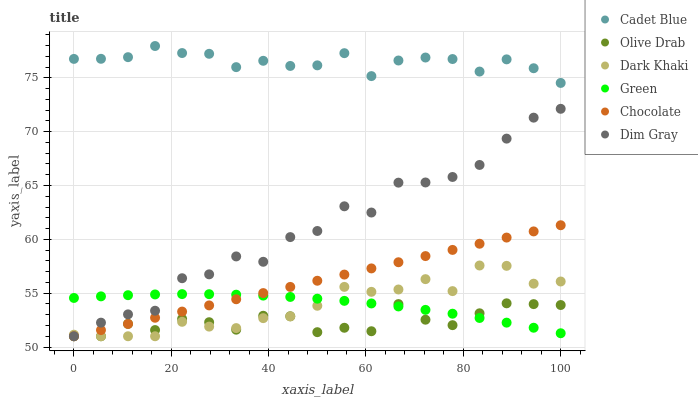Does Olive Drab have the minimum area under the curve?
Answer yes or no. Yes. Does Cadet Blue have the maximum area under the curve?
Answer yes or no. Yes. Does Chocolate have the minimum area under the curve?
Answer yes or no. No. Does Chocolate have the maximum area under the curve?
Answer yes or no. No. Is Chocolate the smoothest?
Answer yes or no. Yes. Is Dim Gray the roughest?
Answer yes or no. Yes. Is Dark Khaki the smoothest?
Answer yes or no. No. Is Dark Khaki the roughest?
Answer yes or no. No. Does Dim Gray have the lowest value?
Answer yes or no. Yes. Does Cadet Blue have the lowest value?
Answer yes or no. No. Does Cadet Blue have the highest value?
Answer yes or no. Yes. Does Chocolate have the highest value?
Answer yes or no. No. Is Green less than Cadet Blue?
Answer yes or no. Yes. Is Cadet Blue greater than Dim Gray?
Answer yes or no. Yes. Does Chocolate intersect Dark Khaki?
Answer yes or no. Yes. Is Chocolate less than Dark Khaki?
Answer yes or no. No. Is Chocolate greater than Dark Khaki?
Answer yes or no. No. Does Green intersect Cadet Blue?
Answer yes or no. No. 